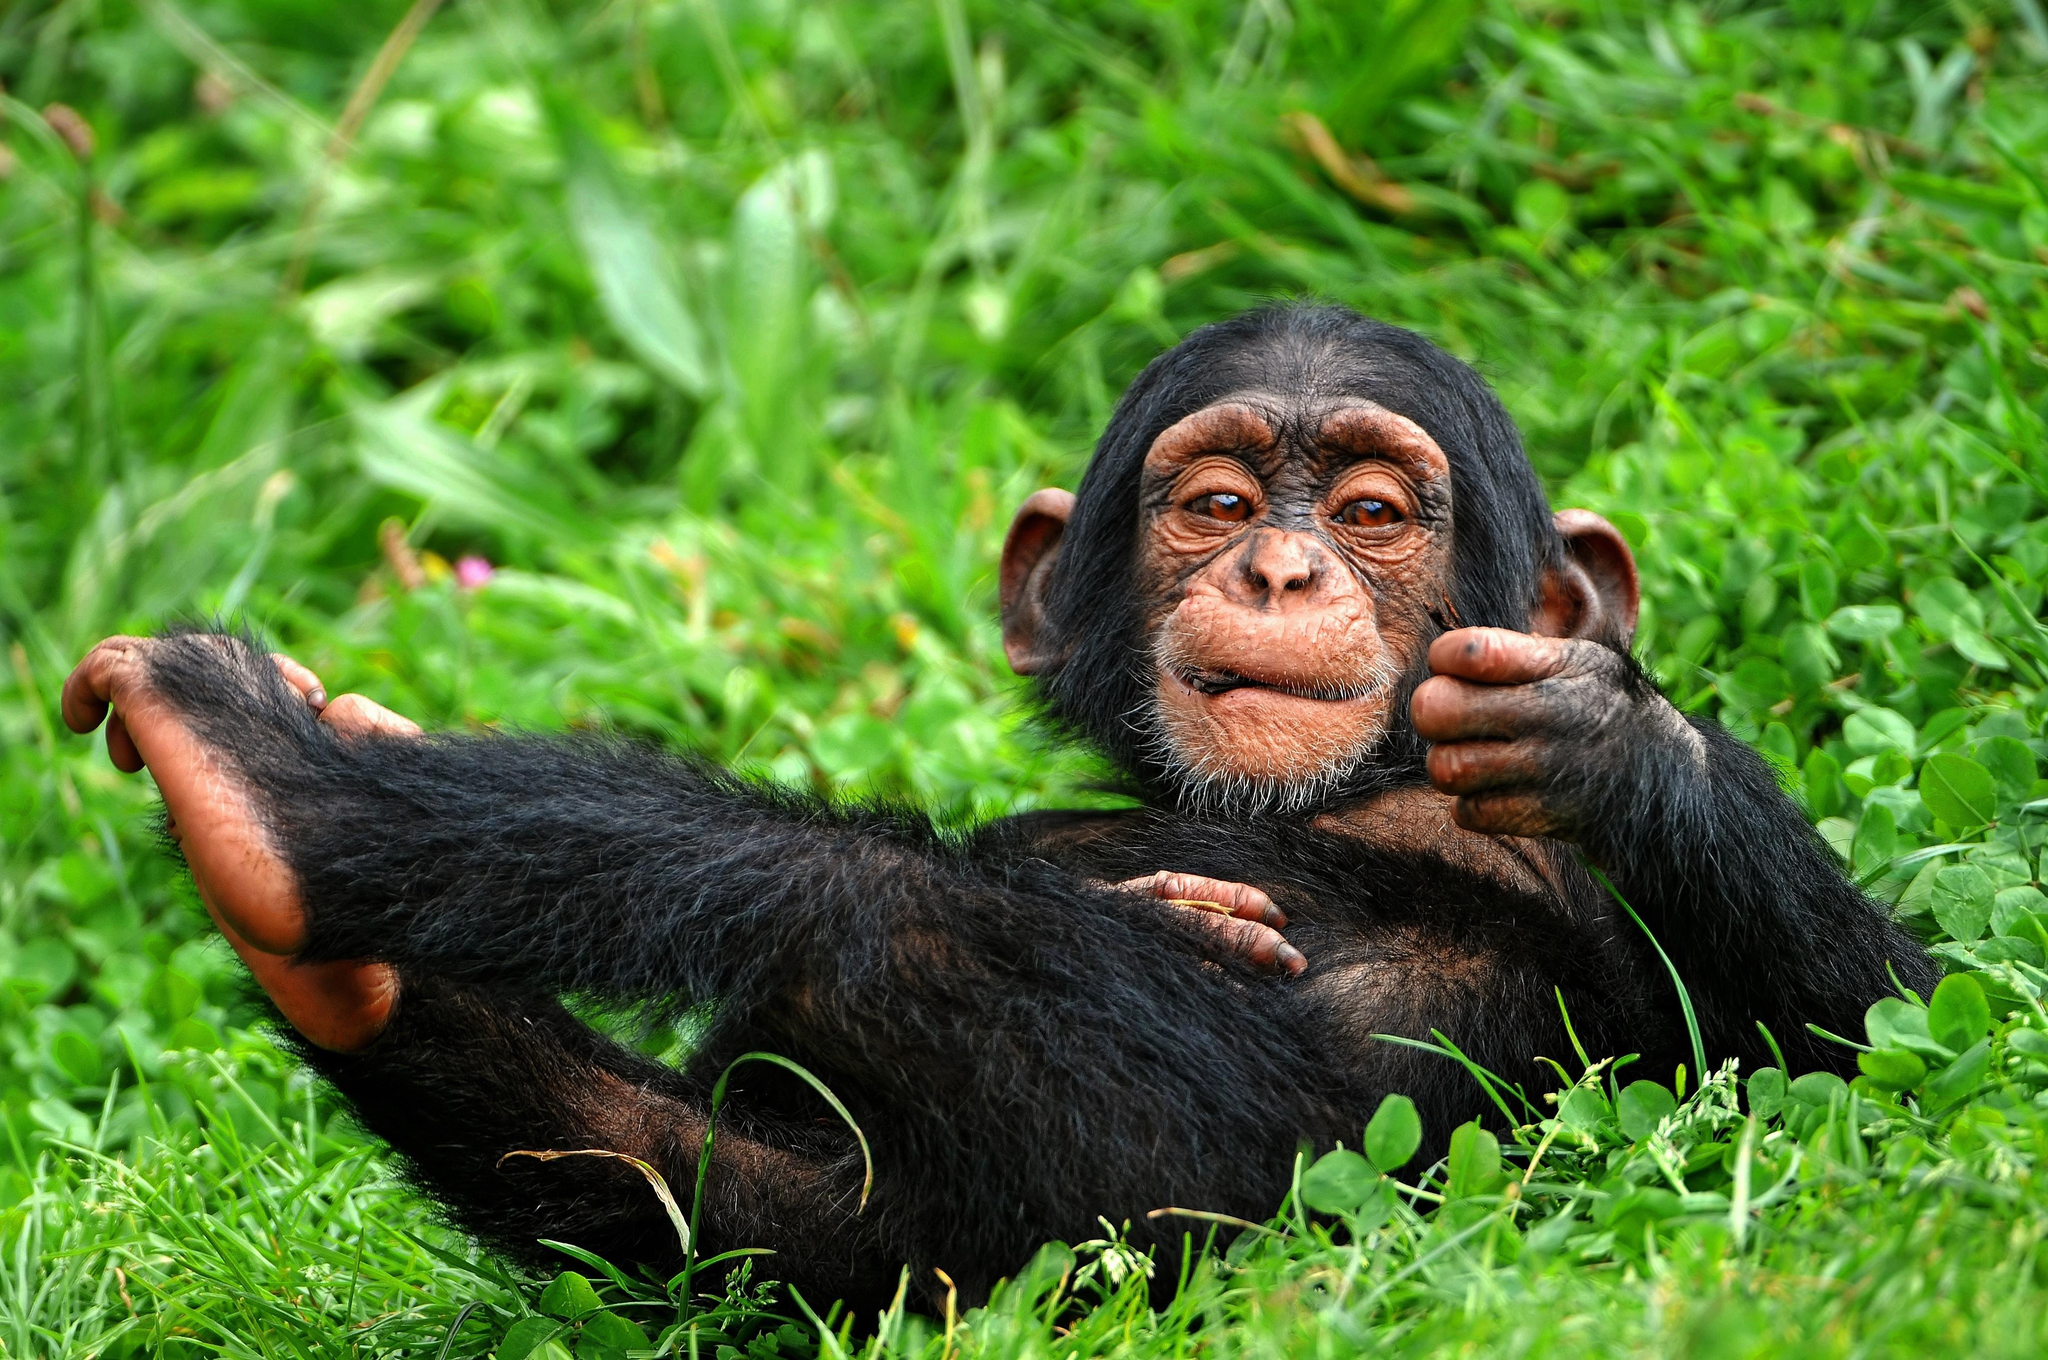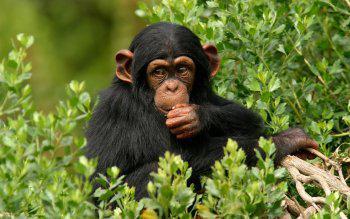The first image is the image on the left, the second image is the image on the right. For the images shown, is this caption "In one of the images, a young chimp places something in its mouth." true? Answer yes or no. Yes. 